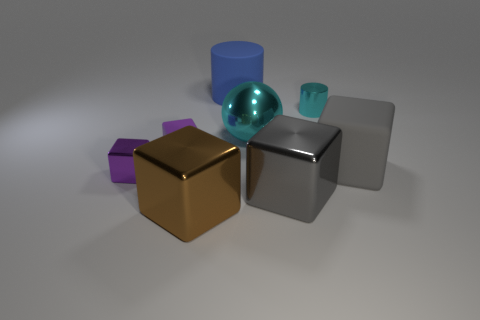Subtract all brown cubes. How many cubes are left? 4 Subtract all brown metallic blocks. How many blocks are left? 4 Subtract all red cubes. Subtract all yellow spheres. How many cubes are left? 5 Add 1 brown blocks. How many objects exist? 9 Subtract all cylinders. How many objects are left? 6 Subtract 0 gray cylinders. How many objects are left? 8 Subtract all small shiny objects. Subtract all big metal spheres. How many objects are left? 5 Add 5 metallic cylinders. How many metallic cylinders are left? 6 Add 4 tiny yellow balls. How many tiny yellow balls exist? 4 